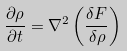<formula> <loc_0><loc_0><loc_500><loc_500>\frac { \partial \rho } { \partial t } = \nabla ^ { 2 } \left ( \frac { \delta F } { \delta \rho } \right ) \</formula> 